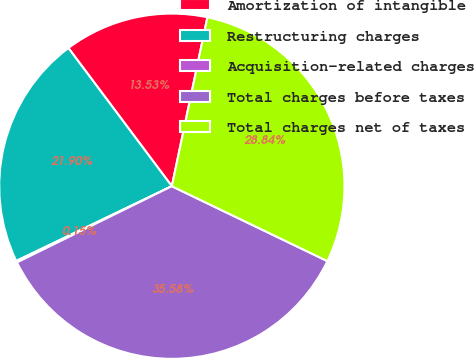Convert chart. <chart><loc_0><loc_0><loc_500><loc_500><pie_chart><fcel>Amortization of intangible<fcel>Restructuring charges<fcel>Acquisition-related charges<fcel>Total charges before taxes<fcel>Total charges net of taxes<nl><fcel>13.53%<fcel>21.9%<fcel>0.15%<fcel>35.58%<fcel>28.84%<nl></chart> 